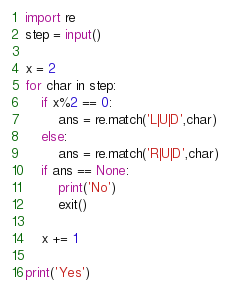<code> <loc_0><loc_0><loc_500><loc_500><_Python_>import re
step = input()

x = 2
for char in step:
	if x%2 == 0:
		ans = re.match('L|U|D',char)
	else:
		ans = re.match('R|U|D',char)
	if ans == None:
		print('No')
		exit()

	x += 1

print('Yes')
</code> 